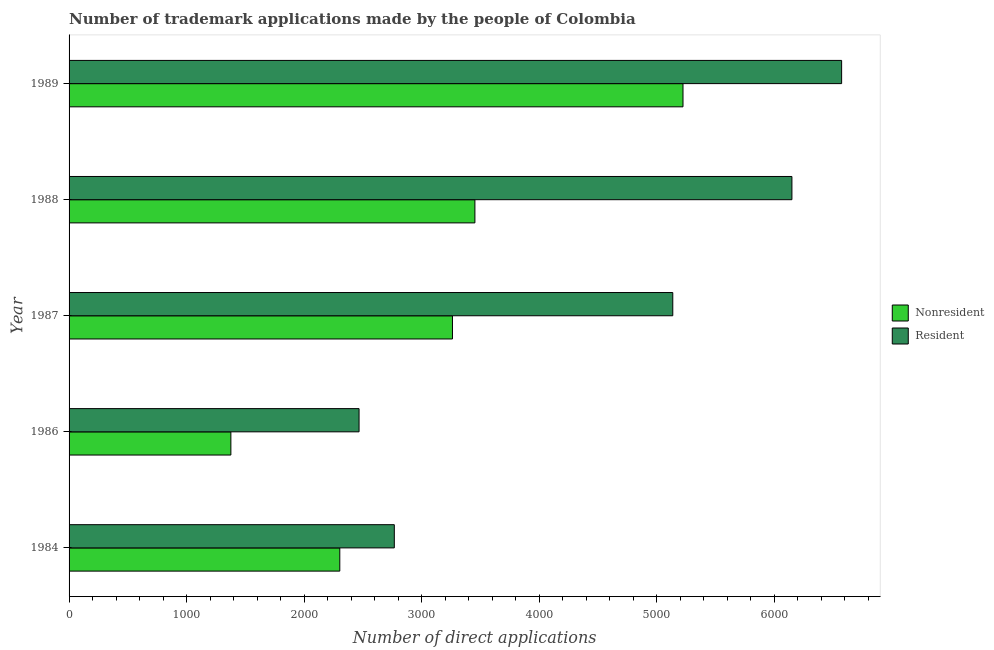How many groups of bars are there?
Keep it short and to the point. 5. In how many cases, is the number of bars for a given year not equal to the number of legend labels?
Offer a very short reply. 0. What is the number of trademark applications made by residents in 1987?
Provide a succinct answer. 5138. Across all years, what is the maximum number of trademark applications made by non residents?
Offer a very short reply. 5225. Across all years, what is the minimum number of trademark applications made by non residents?
Give a very brief answer. 1377. In which year was the number of trademark applications made by residents maximum?
Your answer should be very brief. 1989. What is the total number of trademark applications made by residents in the graph?
Your answer should be very brief. 2.31e+04. What is the difference between the number of trademark applications made by non residents in 1987 and that in 1989?
Ensure brevity in your answer.  -1962. What is the difference between the number of trademark applications made by residents in 1989 and the number of trademark applications made by non residents in 1988?
Keep it short and to the point. 3121. What is the average number of trademark applications made by non residents per year?
Provide a short and direct response. 3124.6. In the year 1988, what is the difference between the number of trademark applications made by residents and number of trademark applications made by non residents?
Offer a terse response. 2698. What is the ratio of the number of trademark applications made by residents in 1984 to that in 1989?
Give a very brief answer. 0.42. Is the number of trademark applications made by non residents in 1986 less than that in 1988?
Ensure brevity in your answer.  Yes. Is the difference between the number of trademark applications made by non residents in 1986 and 1988 greater than the difference between the number of trademark applications made by residents in 1986 and 1988?
Give a very brief answer. Yes. What is the difference between the highest and the second highest number of trademark applications made by residents?
Your answer should be very brief. 423. What is the difference between the highest and the lowest number of trademark applications made by residents?
Offer a very short reply. 4107. In how many years, is the number of trademark applications made by residents greater than the average number of trademark applications made by residents taken over all years?
Ensure brevity in your answer.  3. What does the 2nd bar from the top in 1986 represents?
Provide a short and direct response. Nonresident. What does the 1st bar from the bottom in 1988 represents?
Offer a terse response. Nonresident. How many years are there in the graph?
Your response must be concise. 5. What is the difference between two consecutive major ticks on the X-axis?
Offer a terse response. 1000. Are the values on the major ticks of X-axis written in scientific E-notation?
Your answer should be compact. No. Does the graph contain grids?
Keep it short and to the point. No. Where does the legend appear in the graph?
Make the answer very short. Center right. What is the title of the graph?
Your response must be concise. Number of trademark applications made by the people of Colombia. What is the label or title of the X-axis?
Make the answer very short. Number of direct applications. What is the label or title of the Y-axis?
Your response must be concise. Year. What is the Number of direct applications in Nonresident in 1984?
Ensure brevity in your answer.  2304. What is the Number of direct applications in Resident in 1984?
Give a very brief answer. 2768. What is the Number of direct applications in Nonresident in 1986?
Offer a very short reply. 1377. What is the Number of direct applications of Resident in 1986?
Your answer should be very brief. 2468. What is the Number of direct applications of Nonresident in 1987?
Your response must be concise. 3263. What is the Number of direct applications in Resident in 1987?
Offer a very short reply. 5138. What is the Number of direct applications in Nonresident in 1988?
Your answer should be compact. 3454. What is the Number of direct applications in Resident in 1988?
Your answer should be very brief. 6152. What is the Number of direct applications of Nonresident in 1989?
Your answer should be very brief. 5225. What is the Number of direct applications in Resident in 1989?
Keep it short and to the point. 6575. Across all years, what is the maximum Number of direct applications in Nonresident?
Keep it short and to the point. 5225. Across all years, what is the maximum Number of direct applications of Resident?
Offer a terse response. 6575. Across all years, what is the minimum Number of direct applications in Nonresident?
Provide a succinct answer. 1377. Across all years, what is the minimum Number of direct applications of Resident?
Give a very brief answer. 2468. What is the total Number of direct applications of Nonresident in the graph?
Provide a short and direct response. 1.56e+04. What is the total Number of direct applications of Resident in the graph?
Keep it short and to the point. 2.31e+04. What is the difference between the Number of direct applications of Nonresident in 1984 and that in 1986?
Keep it short and to the point. 927. What is the difference between the Number of direct applications of Resident in 1984 and that in 1986?
Your answer should be very brief. 300. What is the difference between the Number of direct applications of Nonresident in 1984 and that in 1987?
Provide a succinct answer. -959. What is the difference between the Number of direct applications of Resident in 1984 and that in 1987?
Offer a terse response. -2370. What is the difference between the Number of direct applications of Nonresident in 1984 and that in 1988?
Your answer should be compact. -1150. What is the difference between the Number of direct applications in Resident in 1984 and that in 1988?
Give a very brief answer. -3384. What is the difference between the Number of direct applications of Nonresident in 1984 and that in 1989?
Your answer should be very brief. -2921. What is the difference between the Number of direct applications in Resident in 1984 and that in 1989?
Provide a short and direct response. -3807. What is the difference between the Number of direct applications in Nonresident in 1986 and that in 1987?
Keep it short and to the point. -1886. What is the difference between the Number of direct applications in Resident in 1986 and that in 1987?
Make the answer very short. -2670. What is the difference between the Number of direct applications in Nonresident in 1986 and that in 1988?
Make the answer very short. -2077. What is the difference between the Number of direct applications of Resident in 1986 and that in 1988?
Provide a succinct answer. -3684. What is the difference between the Number of direct applications in Nonresident in 1986 and that in 1989?
Keep it short and to the point. -3848. What is the difference between the Number of direct applications in Resident in 1986 and that in 1989?
Ensure brevity in your answer.  -4107. What is the difference between the Number of direct applications of Nonresident in 1987 and that in 1988?
Provide a succinct answer. -191. What is the difference between the Number of direct applications of Resident in 1987 and that in 1988?
Your answer should be compact. -1014. What is the difference between the Number of direct applications of Nonresident in 1987 and that in 1989?
Your answer should be very brief. -1962. What is the difference between the Number of direct applications of Resident in 1987 and that in 1989?
Keep it short and to the point. -1437. What is the difference between the Number of direct applications in Nonresident in 1988 and that in 1989?
Make the answer very short. -1771. What is the difference between the Number of direct applications of Resident in 1988 and that in 1989?
Offer a very short reply. -423. What is the difference between the Number of direct applications in Nonresident in 1984 and the Number of direct applications in Resident in 1986?
Give a very brief answer. -164. What is the difference between the Number of direct applications of Nonresident in 1984 and the Number of direct applications of Resident in 1987?
Ensure brevity in your answer.  -2834. What is the difference between the Number of direct applications of Nonresident in 1984 and the Number of direct applications of Resident in 1988?
Your answer should be compact. -3848. What is the difference between the Number of direct applications in Nonresident in 1984 and the Number of direct applications in Resident in 1989?
Ensure brevity in your answer.  -4271. What is the difference between the Number of direct applications in Nonresident in 1986 and the Number of direct applications in Resident in 1987?
Your response must be concise. -3761. What is the difference between the Number of direct applications in Nonresident in 1986 and the Number of direct applications in Resident in 1988?
Offer a very short reply. -4775. What is the difference between the Number of direct applications in Nonresident in 1986 and the Number of direct applications in Resident in 1989?
Keep it short and to the point. -5198. What is the difference between the Number of direct applications in Nonresident in 1987 and the Number of direct applications in Resident in 1988?
Your answer should be compact. -2889. What is the difference between the Number of direct applications in Nonresident in 1987 and the Number of direct applications in Resident in 1989?
Make the answer very short. -3312. What is the difference between the Number of direct applications of Nonresident in 1988 and the Number of direct applications of Resident in 1989?
Make the answer very short. -3121. What is the average Number of direct applications of Nonresident per year?
Offer a very short reply. 3124.6. What is the average Number of direct applications of Resident per year?
Offer a very short reply. 4620.2. In the year 1984, what is the difference between the Number of direct applications in Nonresident and Number of direct applications in Resident?
Keep it short and to the point. -464. In the year 1986, what is the difference between the Number of direct applications of Nonresident and Number of direct applications of Resident?
Provide a succinct answer. -1091. In the year 1987, what is the difference between the Number of direct applications of Nonresident and Number of direct applications of Resident?
Ensure brevity in your answer.  -1875. In the year 1988, what is the difference between the Number of direct applications in Nonresident and Number of direct applications in Resident?
Give a very brief answer. -2698. In the year 1989, what is the difference between the Number of direct applications of Nonresident and Number of direct applications of Resident?
Your answer should be very brief. -1350. What is the ratio of the Number of direct applications in Nonresident in 1984 to that in 1986?
Give a very brief answer. 1.67. What is the ratio of the Number of direct applications of Resident in 1984 to that in 1986?
Make the answer very short. 1.12. What is the ratio of the Number of direct applications in Nonresident in 1984 to that in 1987?
Your answer should be compact. 0.71. What is the ratio of the Number of direct applications in Resident in 1984 to that in 1987?
Give a very brief answer. 0.54. What is the ratio of the Number of direct applications in Nonresident in 1984 to that in 1988?
Your answer should be compact. 0.67. What is the ratio of the Number of direct applications of Resident in 1984 to that in 1988?
Provide a succinct answer. 0.45. What is the ratio of the Number of direct applications in Nonresident in 1984 to that in 1989?
Your answer should be very brief. 0.44. What is the ratio of the Number of direct applications in Resident in 1984 to that in 1989?
Your answer should be very brief. 0.42. What is the ratio of the Number of direct applications of Nonresident in 1986 to that in 1987?
Offer a terse response. 0.42. What is the ratio of the Number of direct applications of Resident in 1986 to that in 1987?
Your response must be concise. 0.48. What is the ratio of the Number of direct applications of Nonresident in 1986 to that in 1988?
Give a very brief answer. 0.4. What is the ratio of the Number of direct applications in Resident in 1986 to that in 1988?
Your response must be concise. 0.4. What is the ratio of the Number of direct applications in Nonresident in 1986 to that in 1989?
Make the answer very short. 0.26. What is the ratio of the Number of direct applications in Resident in 1986 to that in 1989?
Keep it short and to the point. 0.38. What is the ratio of the Number of direct applications in Nonresident in 1987 to that in 1988?
Keep it short and to the point. 0.94. What is the ratio of the Number of direct applications in Resident in 1987 to that in 1988?
Keep it short and to the point. 0.84. What is the ratio of the Number of direct applications of Nonresident in 1987 to that in 1989?
Offer a terse response. 0.62. What is the ratio of the Number of direct applications of Resident in 1987 to that in 1989?
Provide a short and direct response. 0.78. What is the ratio of the Number of direct applications of Nonresident in 1988 to that in 1989?
Give a very brief answer. 0.66. What is the ratio of the Number of direct applications of Resident in 1988 to that in 1989?
Offer a very short reply. 0.94. What is the difference between the highest and the second highest Number of direct applications of Nonresident?
Provide a short and direct response. 1771. What is the difference between the highest and the second highest Number of direct applications in Resident?
Offer a very short reply. 423. What is the difference between the highest and the lowest Number of direct applications of Nonresident?
Provide a short and direct response. 3848. What is the difference between the highest and the lowest Number of direct applications in Resident?
Your answer should be very brief. 4107. 